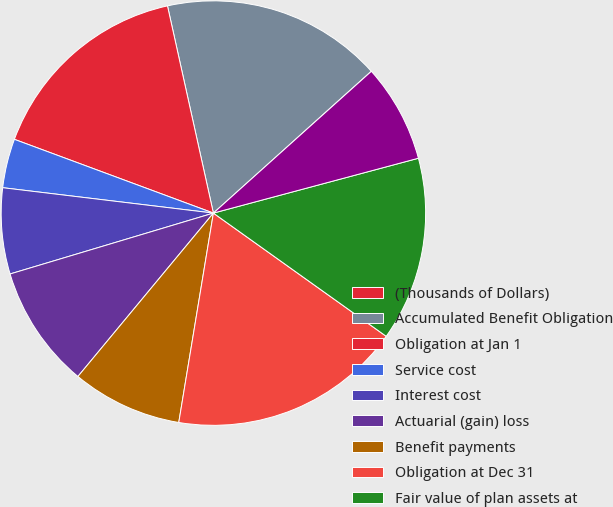Convert chart to OTSL. <chart><loc_0><loc_0><loc_500><loc_500><pie_chart><fcel>(Thousands of Dollars)<fcel>Accumulated Benefit Obligation<fcel>Obligation at Jan 1<fcel>Service cost<fcel>Interest cost<fcel>Actuarial (gain) loss<fcel>Benefit payments<fcel>Obligation at Dec 31<fcel>Fair value of plan assets at<fcel>Actual (loss) return on plan<nl><fcel>0.01%<fcel>16.82%<fcel>15.88%<fcel>3.74%<fcel>6.54%<fcel>9.35%<fcel>8.41%<fcel>17.75%<fcel>14.02%<fcel>7.48%<nl></chart> 